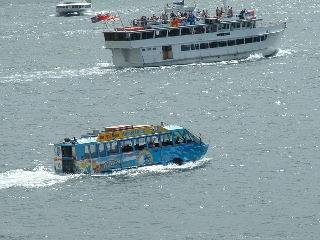How many boats would there be in the image now that one more boat has been moved into the scene? Initially, there are two boats visible in the image. If one more boat has been moved into the scene, there would now be a total of three boats. 